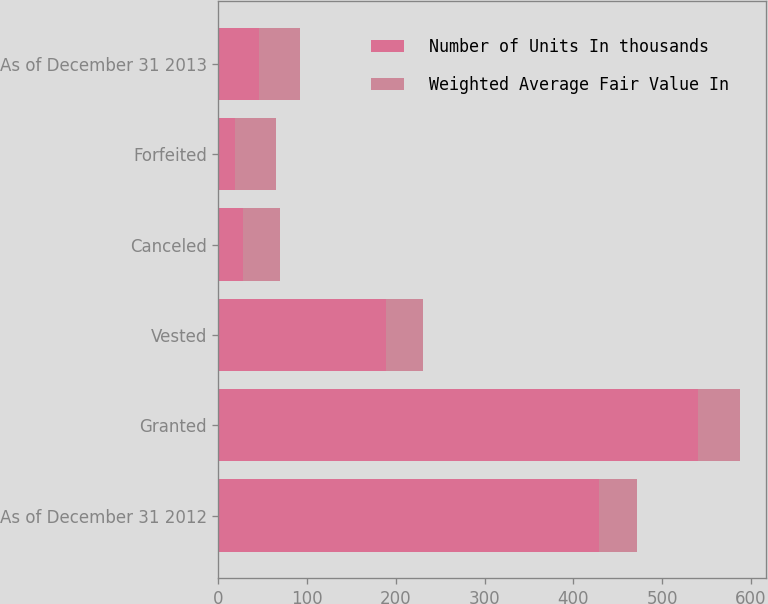Convert chart. <chart><loc_0><loc_0><loc_500><loc_500><stacked_bar_chart><ecel><fcel>As of December 31 2012<fcel>Granted<fcel>Vested<fcel>Canceled<fcel>Forfeited<fcel>As of December 31 2013<nl><fcel>Number of Units In thousands<fcel>429<fcel>540<fcel>189<fcel>28<fcel>19<fcel>46.18<nl><fcel>Weighted Average Fair Value In<fcel>42.22<fcel>47.3<fcel>41.16<fcel>41.16<fcel>46.29<fcel>46.18<nl></chart> 